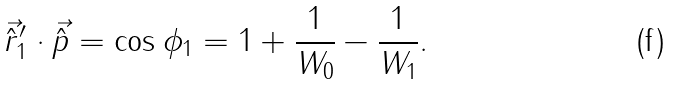Convert formula to latex. <formula><loc_0><loc_0><loc_500><loc_500>\vec { \hat { r } } _ { 1 } ^ { \prime } \cdot \vec { \hat { p } } = \cos { \phi _ { 1 } } = 1 + \frac { 1 } { W _ { 0 } } - \frac { 1 } { W _ { 1 } } .</formula> 